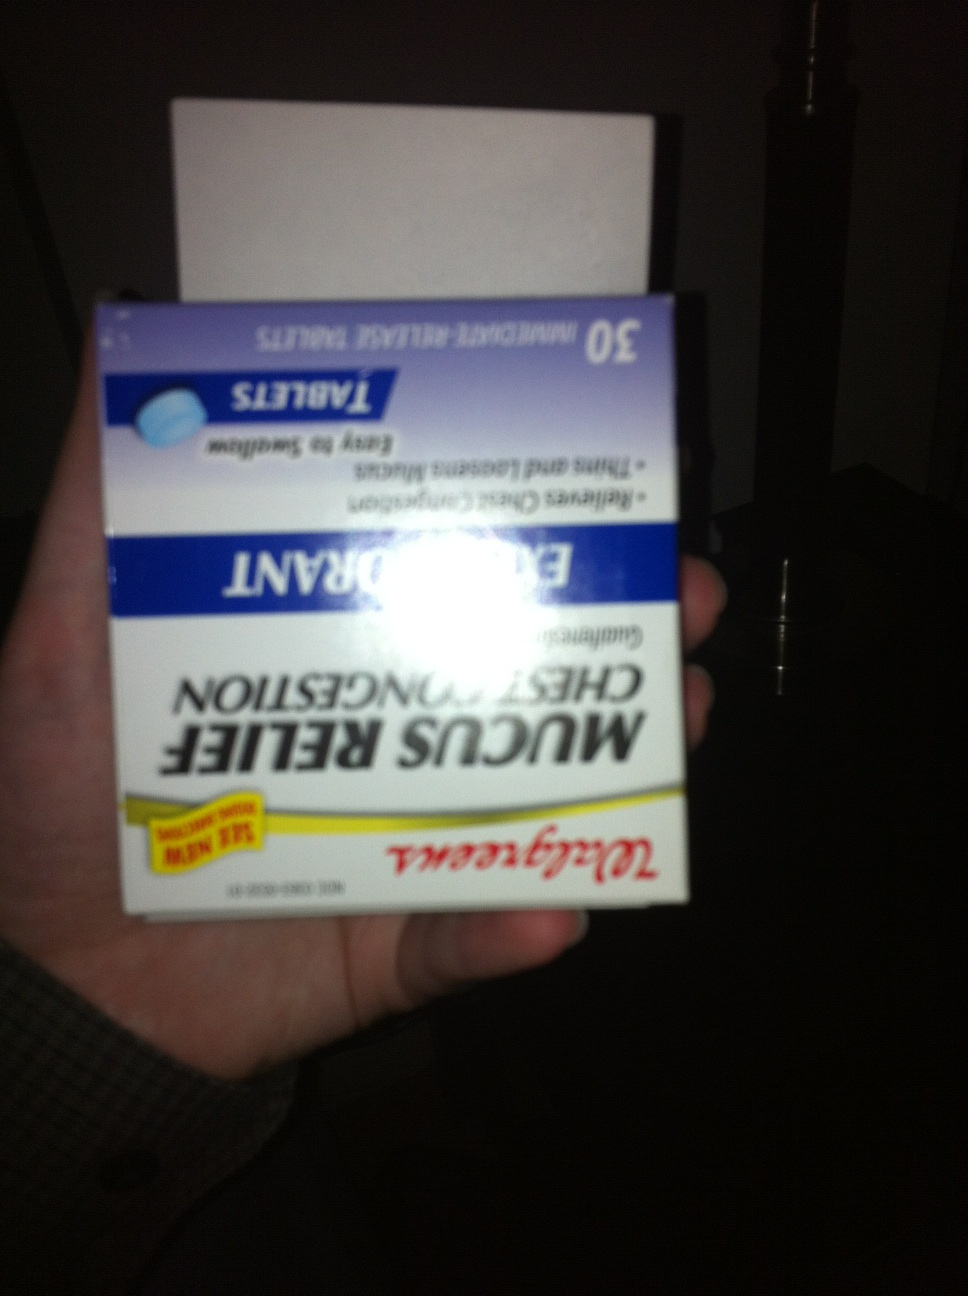Describe a scenario where someone might use this product. A person might use this product during the winter season when they catch a cold and develop a persistent cough with thick mucus that is difficult to expel. They might begin to feel tightness in their chest, making it hard to breathe comfortably. Seeking relief, they go to their local Walgreens and pick up a box of Mucus Relief Chest Congestion tablets. They follow the instructions on the package, take the recommended dose, and start to feel the mucus loosening as they are able to cough it out more easily. Soon, they are able to breathe more freely and feel more comfortable. Can this medication be used for any other conditions? While Walgreens Mucus Relief Chest Congestion is primarily used for relieving symptoms of chest congestion due to colds, it may also be used to ease mucus congestion associated with other respiratory conditions, such as acute bronchitis. However, it is important to consult with a healthcare professional before using this medication for conditions other than the common cold. 